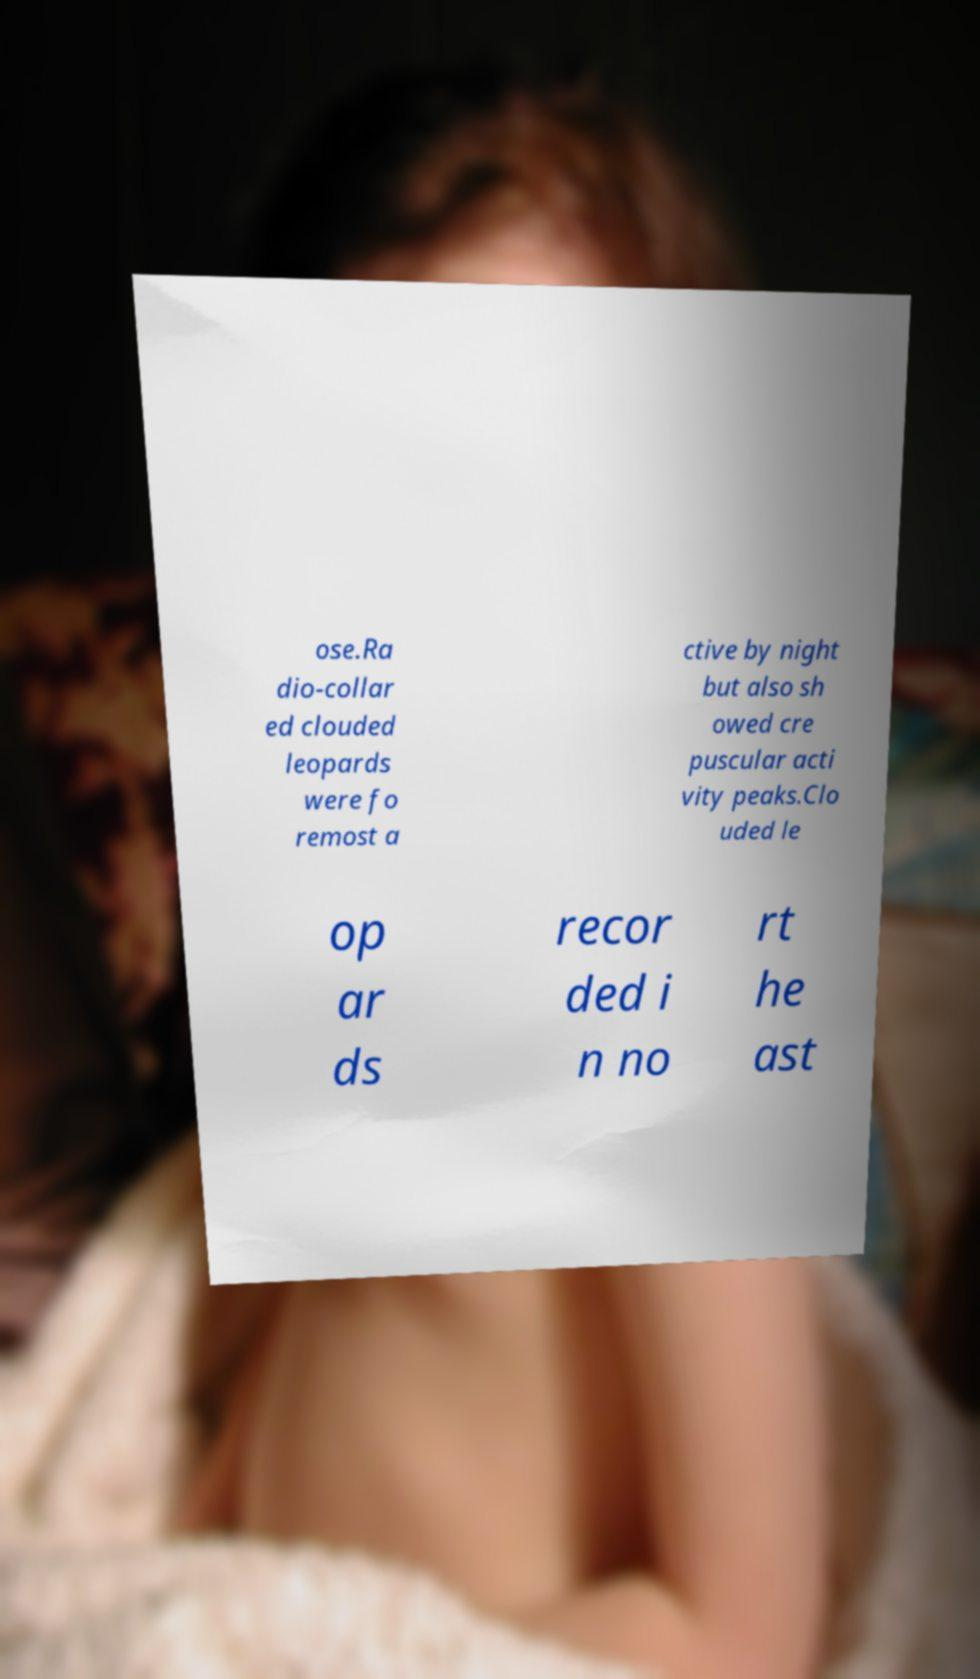Please read and relay the text visible in this image. What does it say? ose.Ra dio-collar ed clouded leopards were fo remost a ctive by night but also sh owed cre puscular acti vity peaks.Clo uded le op ar ds recor ded i n no rt he ast 